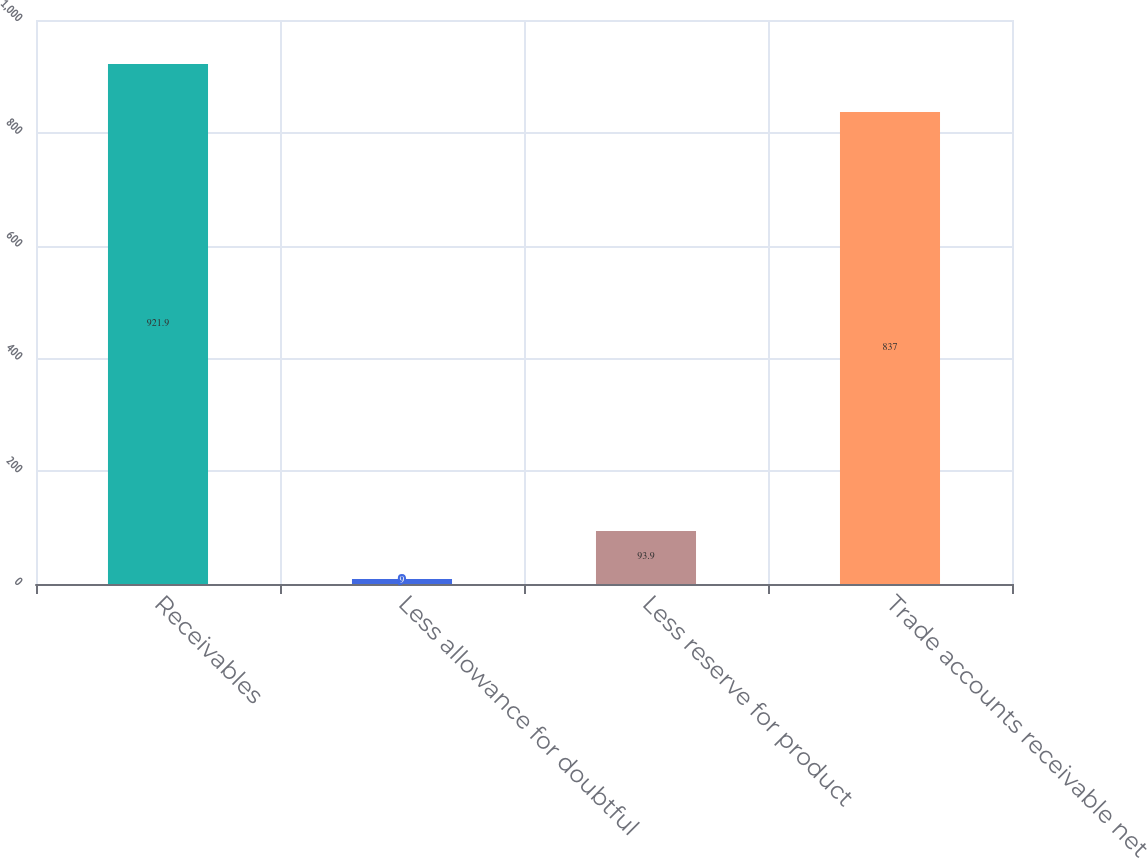<chart> <loc_0><loc_0><loc_500><loc_500><bar_chart><fcel>Receivables<fcel>Less allowance for doubtful<fcel>Less reserve for product<fcel>Trade accounts receivable net<nl><fcel>921.9<fcel>9<fcel>93.9<fcel>837<nl></chart> 